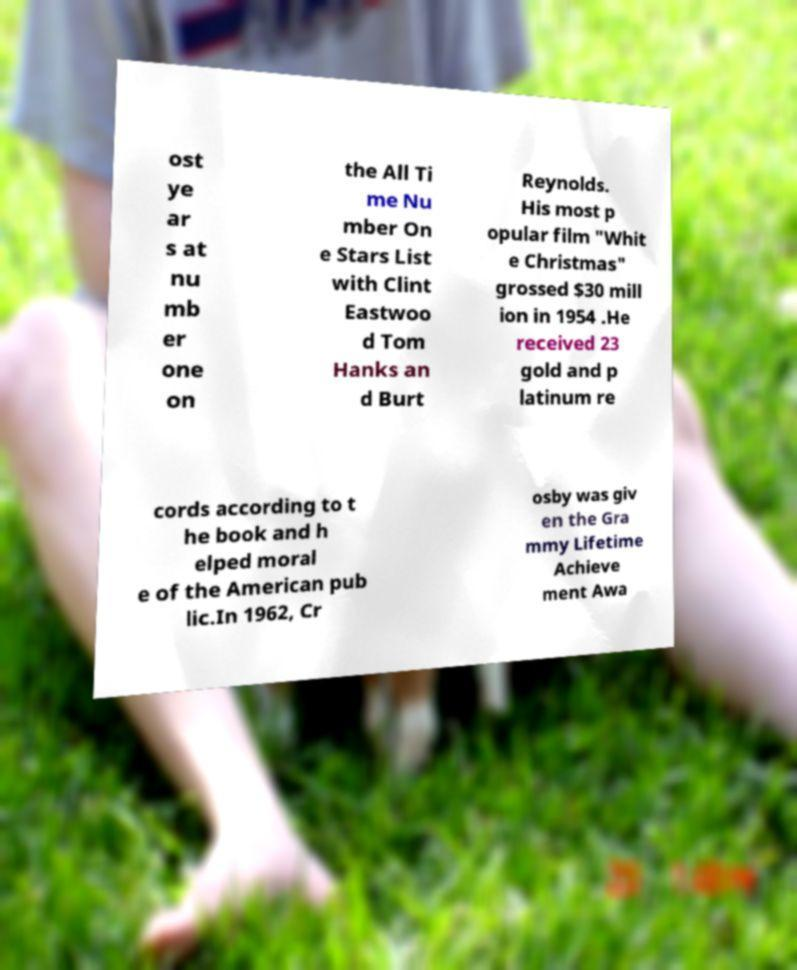Could you assist in decoding the text presented in this image and type it out clearly? ost ye ar s at nu mb er one on the All Ti me Nu mber On e Stars List with Clint Eastwoo d Tom Hanks an d Burt Reynolds. His most p opular film "Whit e Christmas" grossed $30 mill ion in 1954 .He received 23 gold and p latinum re cords according to t he book and h elped moral e of the American pub lic.In 1962, Cr osby was giv en the Gra mmy Lifetime Achieve ment Awa 